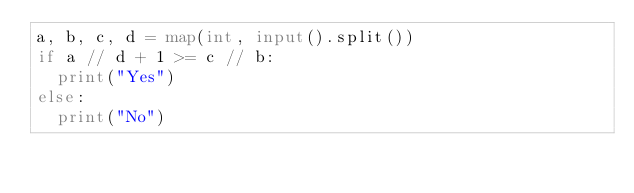Convert code to text. <code><loc_0><loc_0><loc_500><loc_500><_Python_>a, b, c, d = map(int, input().split()) 
if a // d + 1 >= c // b:
  print("Yes")
else:
  print("No")</code> 